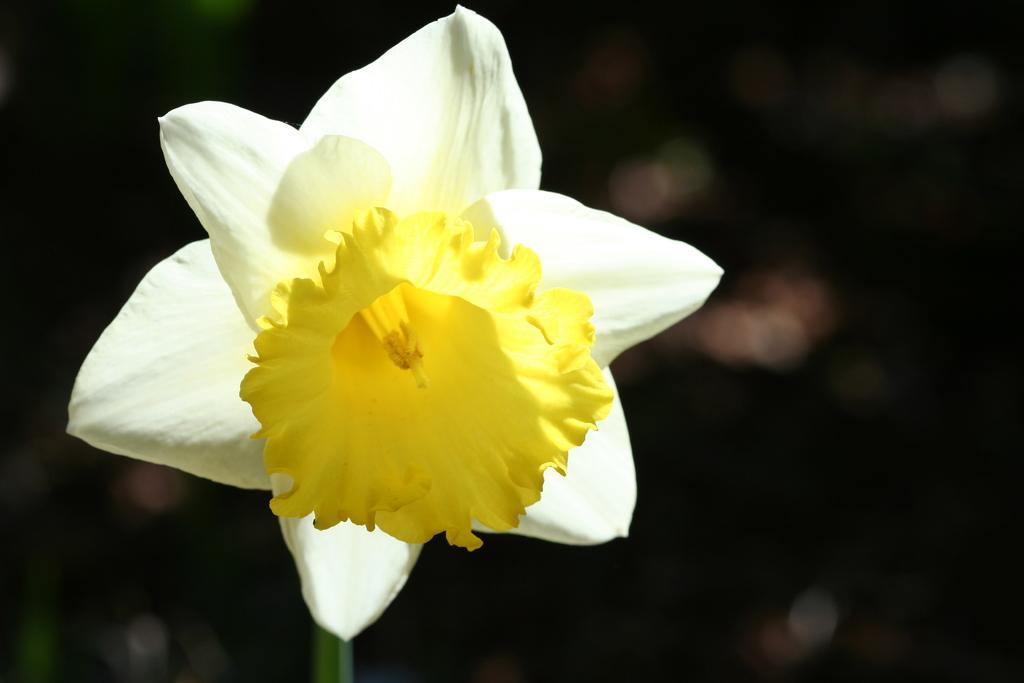Please provide a concise description of this image. In this picture I can see there is a white and yellow flower. The backdrop is blurred. 